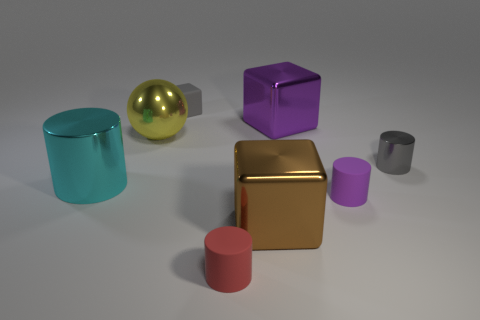Do the large cube behind the tiny purple thing and the thing that is to the left of the large yellow metal ball have the same material?
Keep it short and to the point. Yes. Are any big yellow spheres visible?
Your answer should be compact. Yes. Is the number of big spheres that are to the right of the large purple metal object greater than the number of red cylinders that are on the left side of the big cyan shiny cylinder?
Make the answer very short. No. What material is the other large object that is the same shape as the big purple thing?
Offer a very short reply. Metal. Is there any other thing that has the same size as the shiny sphere?
Provide a short and direct response. Yes. Is the color of the large cube in front of the metallic sphere the same as the large shiny block behind the cyan metallic thing?
Give a very brief answer. No. There is a yellow metallic thing; what shape is it?
Keep it short and to the point. Sphere. Is the number of big shiny cubes that are behind the cyan thing greater than the number of big green metal cubes?
Ensure brevity in your answer.  Yes. What is the shape of the gray thing in front of the tiny gray block?
Offer a terse response. Cylinder. How many other things are there of the same shape as the large purple metallic thing?
Your response must be concise. 2. 